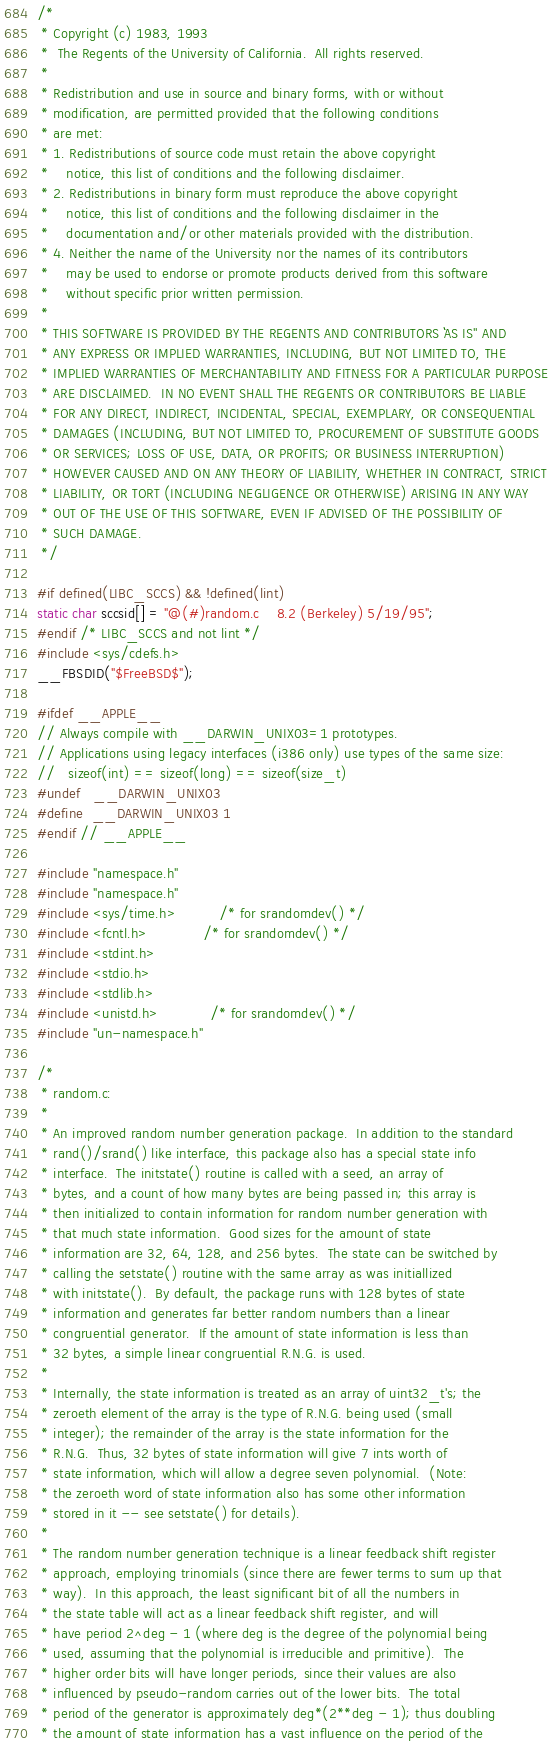<code> <loc_0><loc_0><loc_500><loc_500><_C_>/*
 * Copyright (c) 1983, 1993
 *	The Regents of the University of California.  All rights reserved.
 *
 * Redistribution and use in source and binary forms, with or without
 * modification, are permitted provided that the following conditions
 * are met:
 * 1. Redistributions of source code must retain the above copyright
 *    notice, this list of conditions and the following disclaimer.
 * 2. Redistributions in binary form must reproduce the above copyright
 *    notice, this list of conditions and the following disclaimer in the
 *    documentation and/or other materials provided with the distribution.
 * 4. Neither the name of the University nor the names of its contributors
 *    may be used to endorse or promote products derived from this software
 *    without specific prior written permission.
 *
 * THIS SOFTWARE IS PROVIDED BY THE REGENTS AND CONTRIBUTORS ``AS IS'' AND
 * ANY EXPRESS OR IMPLIED WARRANTIES, INCLUDING, BUT NOT LIMITED TO, THE
 * IMPLIED WARRANTIES OF MERCHANTABILITY AND FITNESS FOR A PARTICULAR PURPOSE
 * ARE DISCLAIMED.  IN NO EVENT SHALL THE REGENTS OR CONTRIBUTORS BE LIABLE
 * FOR ANY DIRECT, INDIRECT, INCIDENTAL, SPECIAL, EXEMPLARY, OR CONSEQUENTIAL
 * DAMAGES (INCLUDING, BUT NOT LIMITED TO, PROCUREMENT OF SUBSTITUTE GOODS
 * OR SERVICES; LOSS OF USE, DATA, OR PROFITS; OR BUSINESS INTERRUPTION)
 * HOWEVER CAUSED AND ON ANY THEORY OF LIABILITY, WHETHER IN CONTRACT, STRICT
 * LIABILITY, OR TORT (INCLUDING NEGLIGENCE OR OTHERWISE) ARISING IN ANY WAY
 * OUT OF THE USE OF THIS SOFTWARE, EVEN IF ADVISED OF THE POSSIBILITY OF
 * SUCH DAMAGE.
 */

#if defined(LIBC_SCCS) && !defined(lint)
static char sccsid[] = "@(#)random.c	8.2 (Berkeley) 5/19/95";
#endif /* LIBC_SCCS and not lint */
#include <sys/cdefs.h>
__FBSDID("$FreeBSD$");

#ifdef __APPLE__
// Always compile with __DARWIN_UNIX03=1 prototypes.
// Applications using legacy interfaces (i386 only) use types of the same size:
//   sizeof(int) == sizeof(long) == sizeof(size_t)
#undef 	__DARWIN_UNIX03
#define	__DARWIN_UNIX03	1
#endif // __APPLE__

#include "namespace.h"
#include "namespace.h"
#include <sys/time.h>          /* for srandomdev() */
#include <fcntl.h>             /* for srandomdev() */
#include <stdint.h>
#include <stdio.h>
#include <stdlib.h>
#include <unistd.h>            /* for srandomdev() */
#include "un-namespace.h"

/*
 * random.c:
 *
 * An improved random number generation package.  In addition to the standard
 * rand()/srand() like interface, this package also has a special state info
 * interface.  The initstate() routine is called with a seed, an array of
 * bytes, and a count of how many bytes are being passed in; this array is
 * then initialized to contain information for random number generation with
 * that much state information.  Good sizes for the amount of state
 * information are 32, 64, 128, and 256 bytes.  The state can be switched by
 * calling the setstate() routine with the same array as was initiallized
 * with initstate().  By default, the package runs with 128 bytes of state
 * information and generates far better random numbers than a linear
 * congruential generator.  If the amount of state information is less than
 * 32 bytes, a simple linear congruential R.N.G. is used.
 *
 * Internally, the state information is treated as an array of uint32_t's; the
 * zeroeth element of the array is the type of R.N.G. being used (small
 * integer); the remainder of the array is the state information for the
 * R.N.G.  Thus, 32 bytes of state information will give 7 ints worth of
 * state information, which will allow a degree seven polynomial.  (Note:
 * the zeroeth word of state information also has some other information
 * stored in it -- see setstate() for details).
 *
 * The random number generation technique is a linear feedback shift register
 * approach, employing trinomials (since there are fewer terms to sum up that
 * way).  In this approach, the least significant bit of all the numbers in
 * the state table will act as a linear feedback shift register, and will
 * have period 2^deg - 1 (where deg is the degree of the polynomial being
 * used, assuming that the polynomial is irreducible and primitive).  The
 * higher order bits will have longer periods, since their values are also
 * influenced by pseudo-random carries out of the lower bits.  The total
 * period of the generator is approximately deg*(2**deg - 1); thus doubling
 * the amount of state information has a vast influence on the period of the</code> 